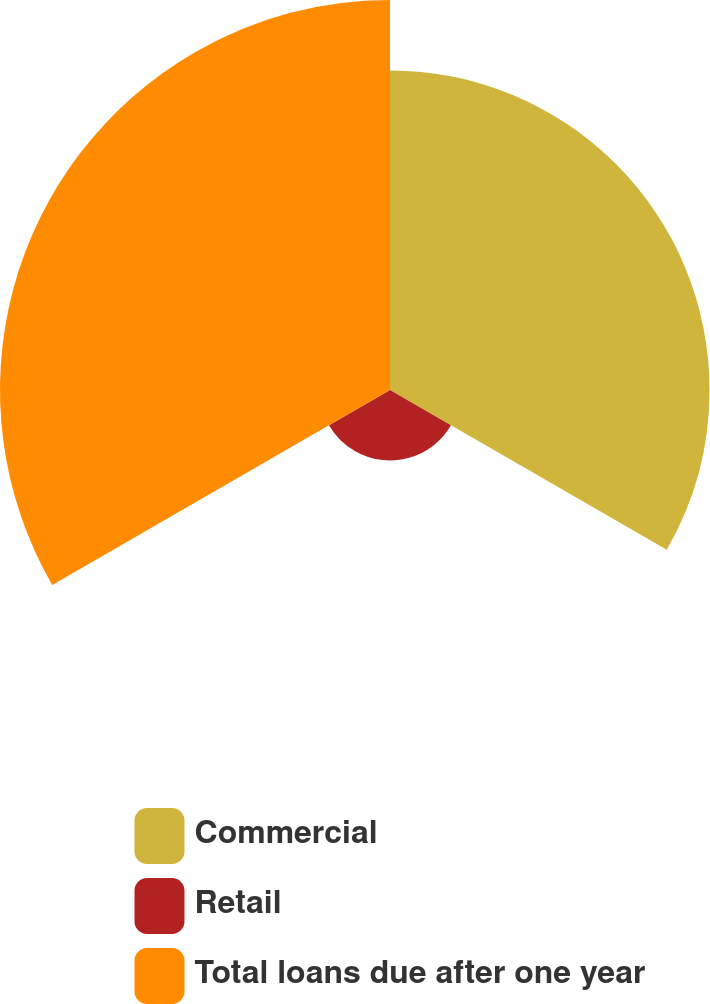Convert chart to OTSL. <chart><loc_0><loc_0><loc_500><loc_500><pie_chart><fcel>Commercial<fcel>Retail<fcel>Total loans due after one year<nl><fcel>40.97%<fcel>9.03%<fcel>50.0%<nl></chart> 